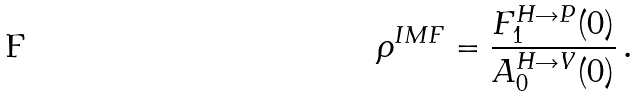<formula> <loc_0><loc_0><loc_500><loc_500>\rho ^ { I M F } = \frac { F _ { 1 } ^ { H \rightarrow P } ( 0 ) } { A _ { 0 } ^ { H \rightarrow V } ( 0 ) } \, .</formula> 